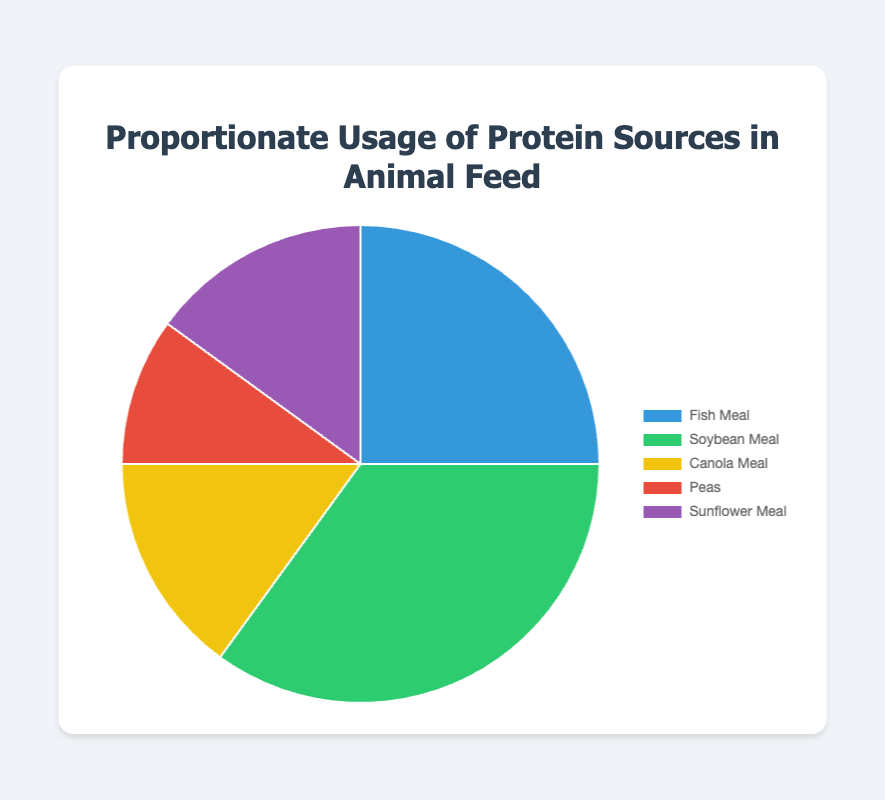What's the largest proportion of protein sources used in feed? According to the pie chart, the protein source with the highest percentage is Soybean Meal, which makes up 35% of the total.
Answer: Soybean Meal Which protein sources make up the same proportion of the feed? From the chart, it is evident that both Canola Meal and Sunflower Meal each contribute 15% to the feed composition.
Answer: Canola Meal, Sunflower Meal What is the combined percentage of Fish Meal and Peas used in the feed? The pie chart shows that Fish Meal makes up 25% and Peas 10%. Adding these percentages together gives 25% + 10% = 35%.
Answer: 35% Which protein source is used the least in the feed? The pie chart indicates that Peas have the smallest proportion at 10%.
Answer: Peas What's the difference in percentage between the highest and lowest protein sources used? The chart shows that Soybean Meal has the highest proportion at 35%, and Peas have the lowest at 10%. The difference is 35% - 10% = 25%.
Answer: 25% If the combined percentage of Canola Meal and Sunflower Meal were doubled, what would it be? Both Canola Meal and Sunflower Meal each have 15%. Their combined percentage is 15% + 15% = 30%. Doubling this amount results in 30% * 2 = 60%.
Answer: 60% What proportion do Sunflower Meal and Peas collectively contribute to the feed mixture? From the pie chart, Sunflower Meal is 15% and Peas are 10%. Their collective contribution is 15% + 10% = 25%.
Answer: 25% What percentage more Soybean Meal is used compared to Canola Meal? The chart shows Soybean Meal is 35% and Canola Meal is 15%. The difference is 35% - 15% = 20%.
Answer: 20% How much of the feed percentage is evenly divided between protein sources except Soybean Meal? Excluding Soybean Meal (35%), the sum of the other sources is Fish Meal (25%), Canola Meal (15%), Peas (10%), and Sunflower Meal (15%), making a total of 25% + 15% + 10% + 15% = 65%. Dividing this equally among the four sources gives 65% / 4 = 16.25%.
Answer: 16.25% 